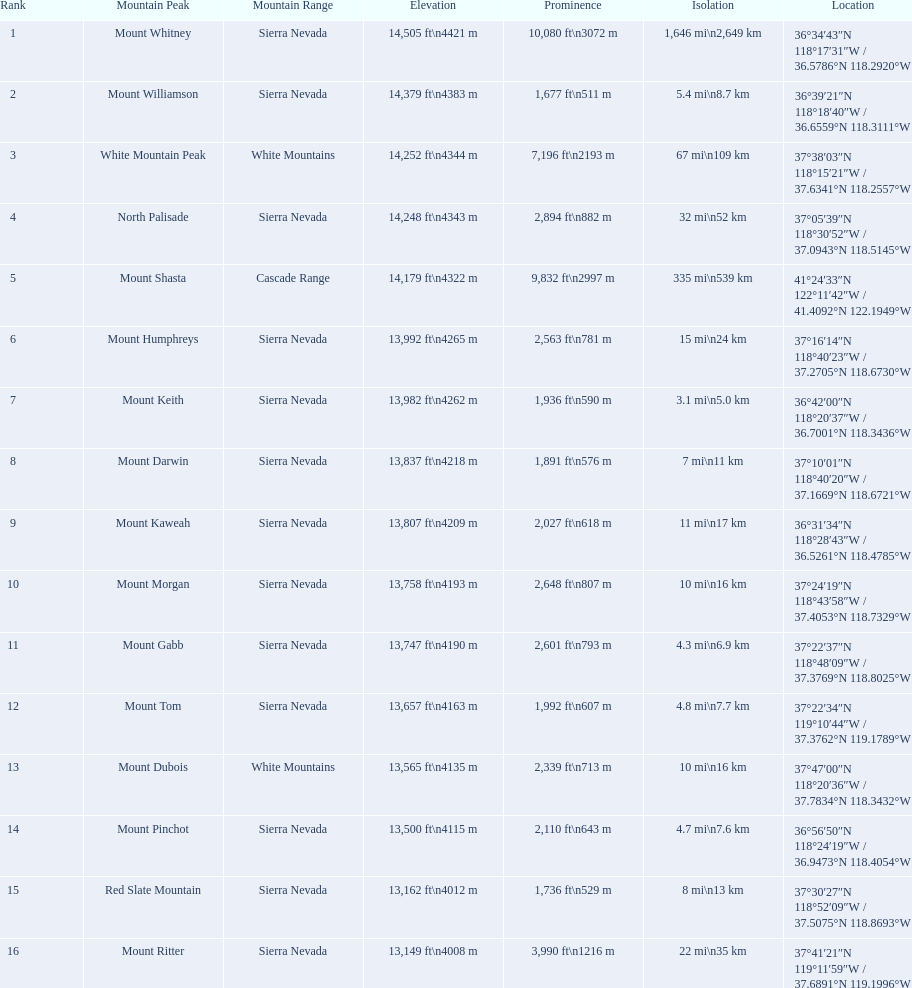What is the name of the mountain peak in the sierra nevada mountain range? Mount Whitney. Which peak reaches 14,379 feet in elevation? Mount Williamson. Which mountain is part of the cascade range? Mount Shasta. 